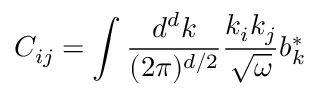<formula> <loc_0><loc_0><loc_500><loc_500>C _ { i j } = \int \frac { d ^ { d } k } { ( 2 \pi ) ^ { d / 2 } } \frac { k _ { i } k _ { j } } { \sqrt { \omega } } b _ { k } ^ { * }</formula> 